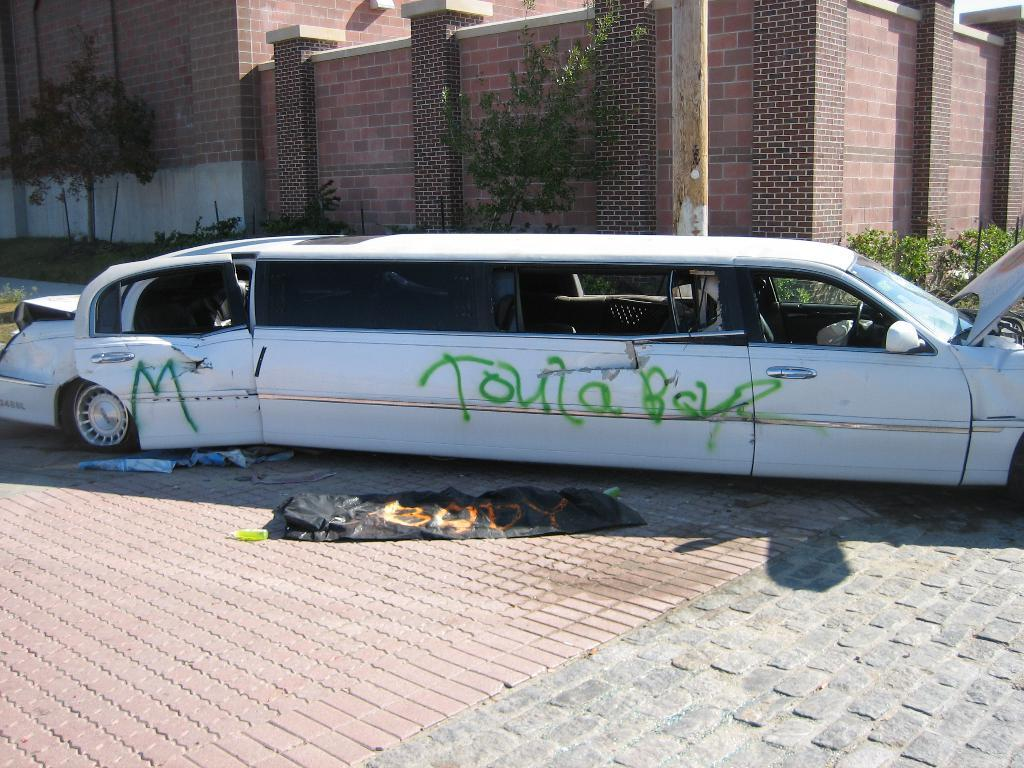What type of vehicle is on the road in the image? There is a Limousin on the road in the image. What can be seen in the background of the image? There are plants and buildings in the background of the image. What is present on the road at the bottom of the image? There are banners on the road at the bottom of the image. What fact is being debated by the committee in the image? There is no committee present in the image, and therefore no debate or fact can be observed. 